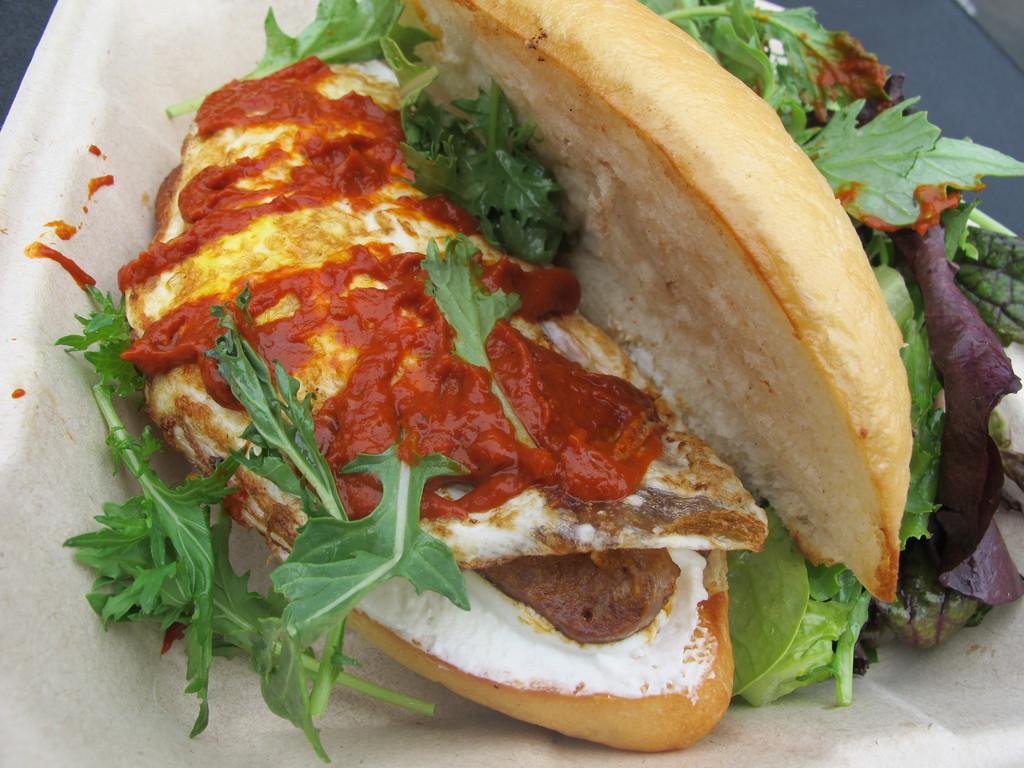How would you summarize this image in a sentence or two? In this image we can see a food item on the white surface. 